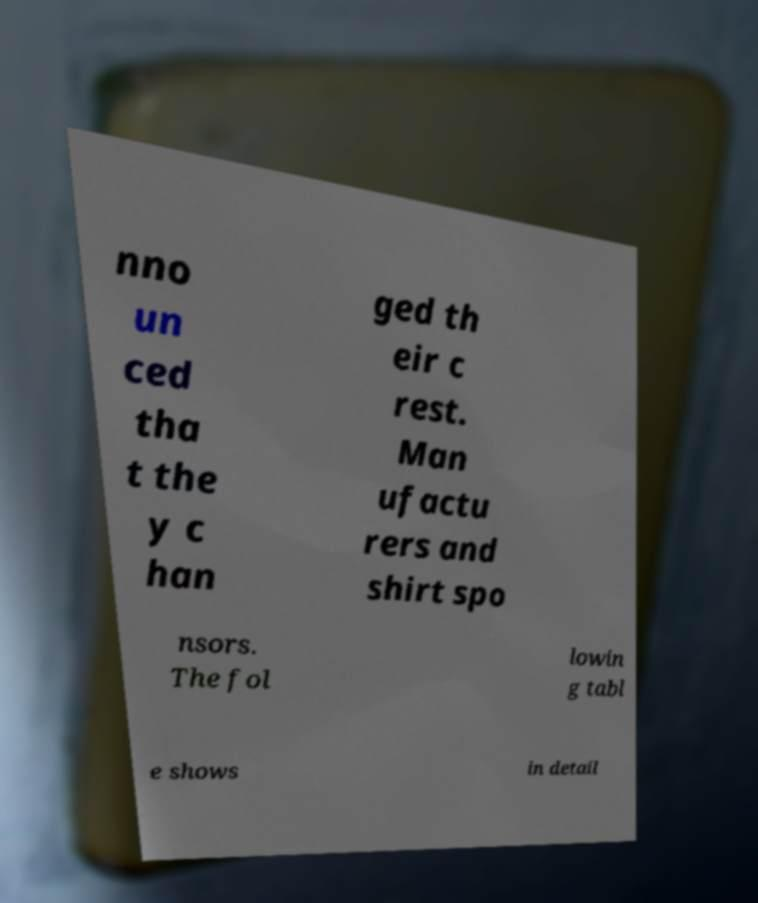Please read and relay the text visible in this image. What does it say? nno un ced tha t the y c han ged th eir c rest. Man ufactu rers and shirt spo nsors. The fol lowin g tabl e shows in detail 